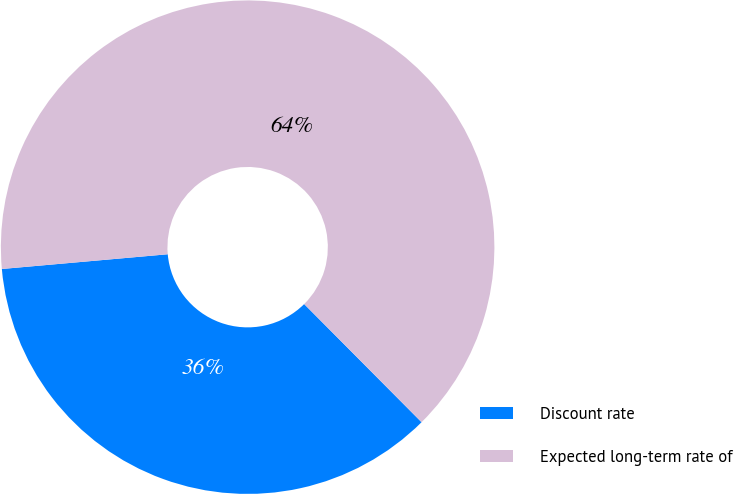Convert chart to OTSL. <chart><loc_0><loc_0><loc_500><loc_500><pie_chart><fcel>Discount rate<fcel>Expected long-term rate of<nl><fcel>36.04%<fcel>63.96%<nl></chart> 